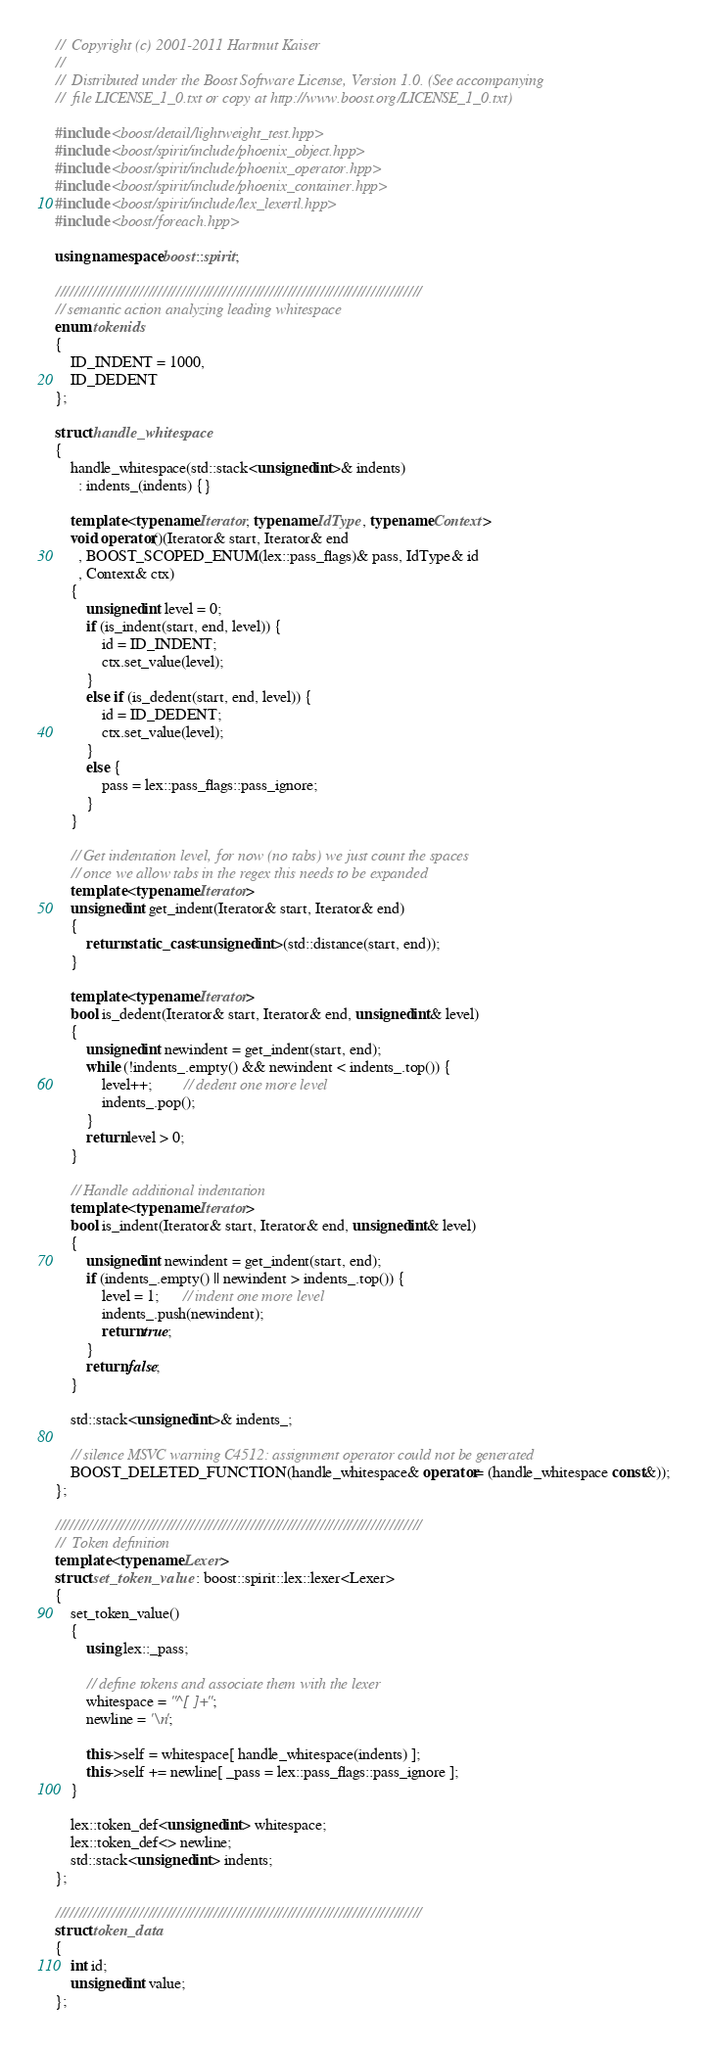<code> <loc_0><loc_0><loc_500><loc_500><_C++_>//  Copyright (c) 2001-2011 Hartmut Kaiser
// 
//  Distributed under the Boost Software License, Version 1.0. (See accompanying 
//  file LICENSE_1_0.txt or copy at http://www.boost.org/LICENSE_1_0.txt)

#include <boost/detail/lightweight_test.hpp>
#include <boost/spirit/include/phoenix_object.hpp>
#include <boost/spirit/include/phoenix_operator.hpp>
#include <boost/spirit/include/phoenix_container.hpp>
#include <boost/spirit/include/lex_lexertl.hpp>
#include <boost/foreach.hpp>

using namespace boost::spirit;

///////////////////////////////////////////////////////////////////////////////
// semantic action analyzing leading whitespace 
enum tokenids
{
    ID_INDENT = 1000,
    ID_DEDENT
};

struct handle_whitespace
{
    handle_whitespace(std::stack<unsigned int>& indents)
      : indents_(indents) {}

    template <typename Iterator, typename IdType, typename Context>
    void operator()(Iterator& start, Iterator& end
      , BOOST_SCOPED_ENUM(lex::pass_flags)& pass, IdType& id
      , Context& ctx)
    {
        unsigned int level = 0;
        if (is_indent(start, end, level)) {
            id = ID_INDENT;
            ctx.set_value(level);
        }
        else if (is_dedent(start, end, level)) {
            id = ID_DEDENT;
            ctx.set_value(level);
        }
        else {
            pass = lex::pass_flags::pass_ignore;
        }
    }

    // Get indentation level, for now (no tabs) we just count the spaces
    // once we allow tabs in the regex this needs to be expanded
    template <typename Iterator>
    unsigned int get_indent(Iterator& start, Iterator& end)
    {
        return static_cast<unsigned int>(std::distance(start, end));
    }

    template <typename Iterator>
    bool is_dedent(Iterator& start, Iterator& end, unsigned int& level) 
    {
        unsigned int newindent = get_indent(start, end);
        while (!indents_.empty() && newindent < indents_.top()) {
            level++;        // dedent one more level
            indents_.pop();
        }
        return level > 0;
    }

    // Handle additional indentation
    template <typename Iterator>
    bool is_indent(Iterator& start, Iterator& end, unsigned int& level) 
    {
        unsigned int newindent = get_indent(start, end);
        if (indents_.empty() || newindent > indents_.top()) {
            level = 1;      // indent one more level 
            indents_.push(newindent);
            return true;
        }
        return false;
    }

    std::stack<unsigned int>& indents_;

    // silence MSVC warning C4512: assignment operator could not be generated
    BOOST_DELETED_FUNCTION(handle_whitespace& operator= (handle_whitespace const&));
};

///////////////////////////////////////////////////////////////////////////////
//  Token definition
template <typename Lexer>
struct set_token_value : boost::spirit::lex::lexer<Lexer>
{
    set_token_value()
    {
        using lex::_pass;

        // define tokens and associate them with the lexer
        whitespace = "^[ ]+";
        newline = '\n';

        this->self = whitespace[ handle_whitespace(indents) ];
        this->self += newline[ _pass = lex::pass_flags::pass_ignore ];
    }

    lex::token_def<unsigned int> whitespace;
    lex::token_def<> newline;
    std::stack<unsigned int> indents;
};

///////////////////////////////////////////////////////////////////////////////
struct token_data
{
    int id;
    unsigned int value;
};
</code> 